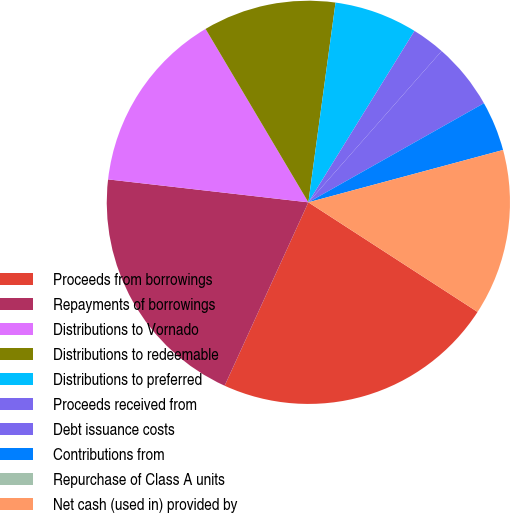Convert chart. <chart><loc_0><loc_0><loc_500><loc_500><pie_chart><fcel>Proceeds from borrowings<fcel>Repayments of borrowings<fcel>Distributions to Vornado<fcel>Distributions to redeemable<fcel>Distributions to preferred<fcel>Proceeds received from<fcel>Debt issuance costs<fcel>Contributions from<fcel>Repurchase of Class A units<fcel>Net cash (used in) provided by<nl><fcel>22.67%<fcel>20.0%<fcel>14.67%<fcel>10.67%<fcel>6.67%<fcel>2.67%<fcel>5.33%<fcel>4.0%<fcel>0.0%<fcel>13.33%<nl></chart> 